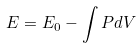<formula> <loc_0><loc_0><loc_500><loc_500>E = E _ { 0 } - \int P d V</formula> 